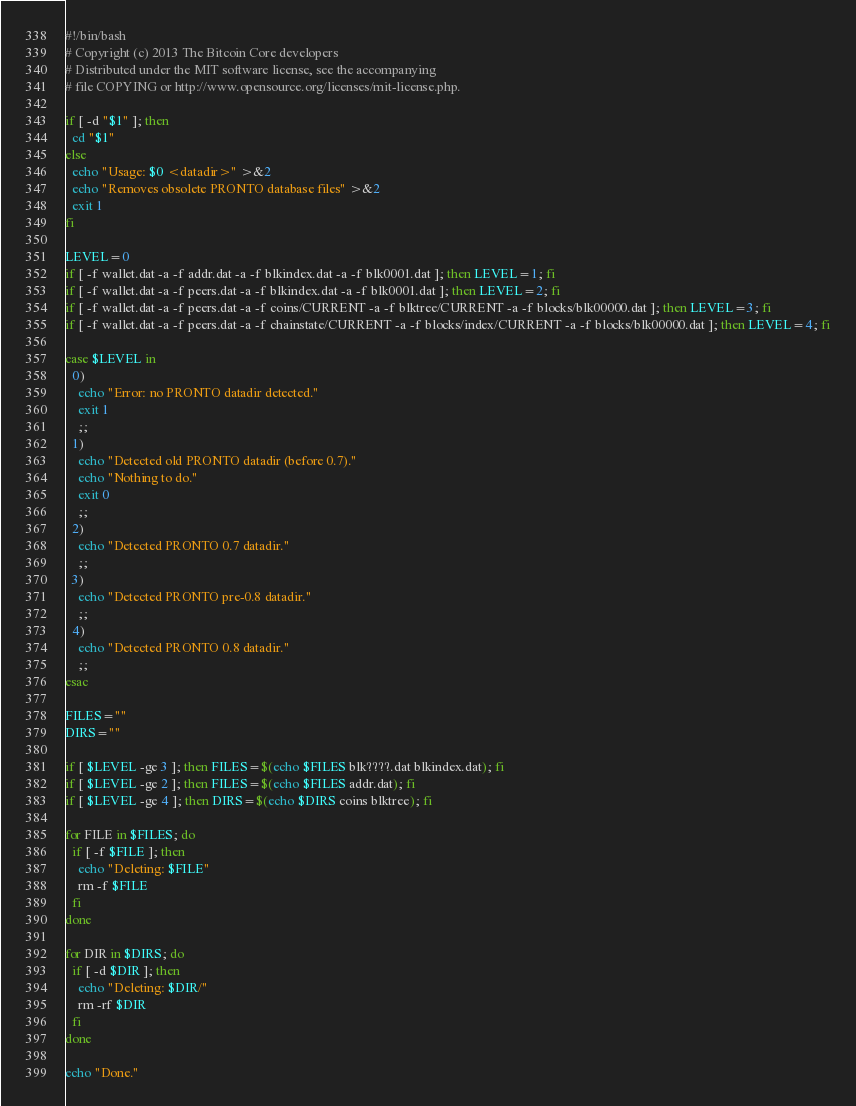Convert code to text. <code><loc_0><loc_0><loc_500><loc_500><_Bash_>#!/bin/bash
# Copyright (c) 2013 The Bitcoin Core developers
# Distributed under the MIT software license, see the accompanying
# file COPYING or http://www.opensource.org/licenses/mit-license.php.

if [ -d "$1" ]; then
  cd "$1"
else
  echo "Usage: $0 <datadir>" >&2
  echo "Removes obsolete PRONTO database files" >&2
  exit 1
fi

LEVEL=0
if [ -f wallet.dat -a -f addr.dat -a -f blkindex.dat -a -f blk0001.dat ]; then LEVEL=1; fi
if [ -f wallet.dat -a -f peers.dat -a -f blkindex.dat -a -f blk0001.dat ]; then LEVEL=2; fi
if [ -f wallet.dat -a -f peers.dat -a -f coins/CURRENT -a -f blktree/CURRENT -a -f blocks/blk00000.dat ]; then LEVEL=3; fi
if [ -f wallet.dat -a -f peers.dat -a -f chainstate/CURRENT -a -f blocks/index/CURRENT -a -f blocks/blk00000.dat ]; then LEVEL=4; fi

case $LEVEL in
  0)
    echo "Error: no PRONTO datadir detected."
    exit 1
    ;;
  1)
    echo "Detected old PRONTO datadir (before 0.7)."
    echo "Nothing to do."
    exit 0
    ;;
  2)
    echo "Detected PRONTO 0.7 datadir."
    ;;
  3)
    echo "Detected PRONTO pre-0.8 datadir."
    ;;
  4)
    echo "Detected PRONTO 0.8 datadir."
    ;;
esac

FILES=""
DIRS=""

if [ $LEVEL -ge 3 ]; then FILES=$(echo $FILES blk????.dat blkindex.dat); fi
if [ $LEVEL -ge 2 ]; then FILES=$(echo $FILES addr.dat); fi
if [ $LEVEL -ge 4 ]; then DIRS=$(echo $DIRS coins blktree); fi

for FILE in $FILES; do
  if [ -f $FILE ]; then
    echo "Deleting: $FILE"
    rm -f $FILE
  fi
done

for DIR in $DIRS; do
  if [ -d $DIR ]; then
    echo "Deleting: $DIR/"
    rm -rf $DIR
  fi
done

echo "Done."
</code> 